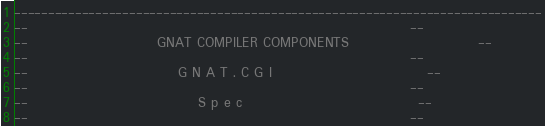Convert code to text. <code><loc_0><loc_0><loc_500><loc_500><_Ada_>------------------------------------------------------------------------------
--                                                                          --
--                         GNAT COMPILER COMPONENTS                         --
--                                                                          --
--                             G N A T . C G I                              --
--                                                                          --
--                                 S p e c                                  --
--                                                                          --</code> 